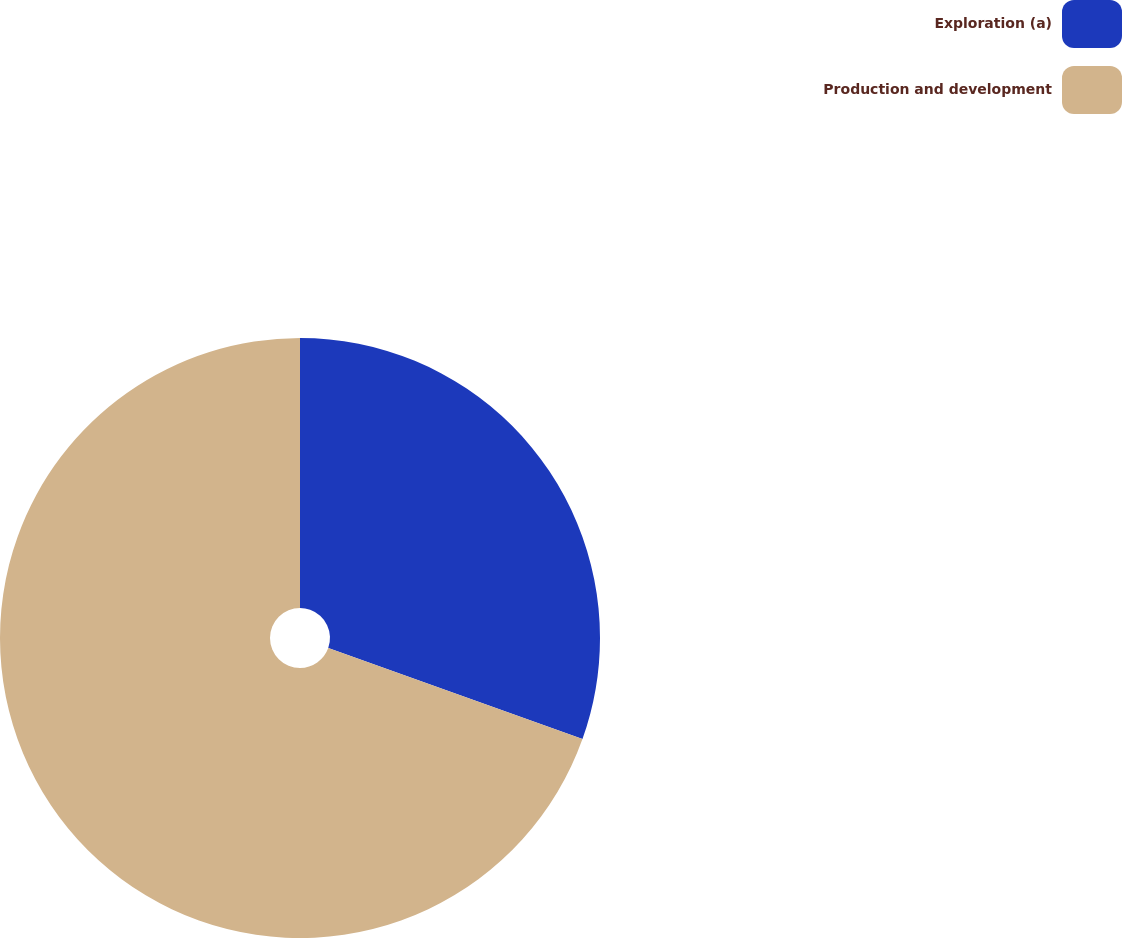Convert chart to OTSL. <chart><loc_0><loc_0><loc_500><loc_500><pie_chart><fcel>Exploration (a)<fcel>Production and development<nl><fcel>30.47%<fcel>69.53%<nl></chart> 